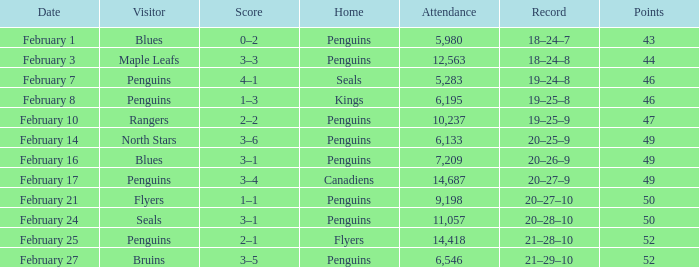What is the history of a 2-1 result? 21–28–10. 